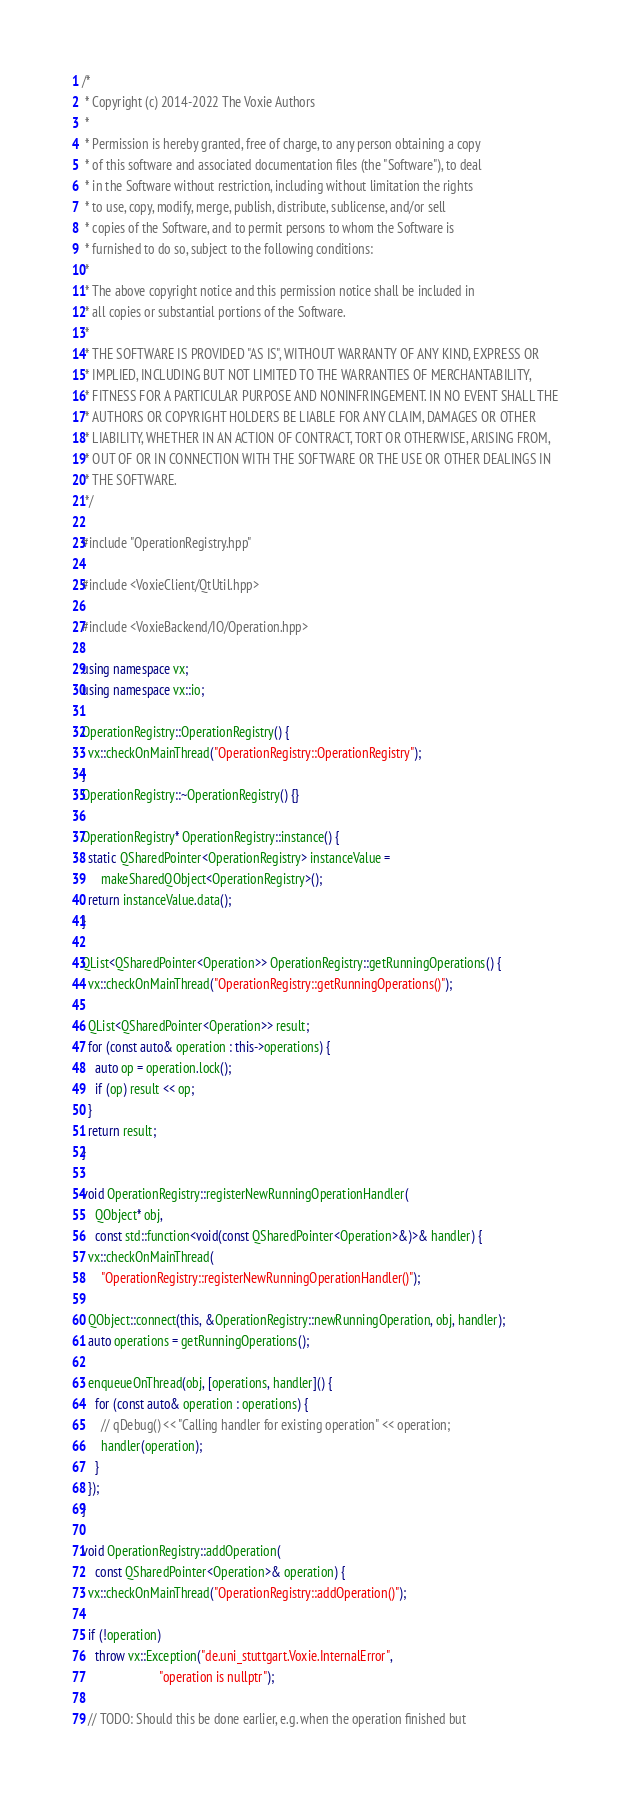Convert code to text. <code><loc_0><loc_0><loc_500><loc_500><_C++_>/*
 * Copyright (c) 2014-2022 The Voxie Authors
 *
 * Permission is hereby granted, free of charge, to any person obtaining a copy
 * of this software and associated documentation files (the "Software"), to deal
 * in the Software without restriction, including without limitation the rights
 * to use, copy, modify, merge, publish, distribute, sublicense, and/or sell
 * copies of the Software, and to permit persons to whom the Software is
 * furnished to do so, subject to the following conditions:
 *
 * The above copyright notice and this permission notice shall be included in
 * all copies or substantial portions of the Software.
 *
 * THE SOFTWARE IS PROVIDED "AS IS", WITHOUT WARRANTY OF ANY KIND, EXPRESS OR
 * IMPLIED, INCLUDING BUT NOT LIMITED TO THE WARRANTIES OF MERCHANTABILITY,
 * FITNESS FOR A PARTICULAR PURPOSE AND NONINFRINGEMENT. IN NO EVENT SHALL THE
 * AUTHORS OR COPYRIGHT HOLDERS BE LIABLE FOR ANY CLAIM, DAMAGES OR OTHER
 * LIABILITY, WHETHER IN AN ACTION OF CONTRACT, TORT OR OTHERWISE, ARISING FROM,
 * OUT OF OR IN CONNECTION WITH THE SOFTWARE OR THE USE OR OTHER DEALINGS IN
 * THE SOFTWARE.
 */

#include "OperationRegistry.hpp"

#include <VoxieClient/QtUtil.hpp>

#include <VoxieBackend/IO/Operation.hpp>

using namespace vx;
using namespace vx::io;

OperationRegistry::OperationRegistry() {
  vx::checkOnMainThread("OperationRegistry::OperationRegistry");
}
OperationRegistry::~OperationRegistry() {}

OperationRegistry* OperationRegistry::instance() {
  static QSharedPointer<OperationRegistry> instanceValue =
      makeSharedQObject<OperationRegistry>();
  return instanceValue.data();
}

QList<QSharedPointer<Operation>> OperationRegistry::getRunningOperations() {
  vx::checkOnMainThread("OperationRegistry::getRunningOperations()");

  QList<QSharedPointer<Operation>> result;
  for (const auto& operation : this->operations) {
    auto op = operation.lock();
    if (op) result << op;
  }
  return result;
}

void OperationRegistry::registerNewRunningOperationHandler(
    QObject* obj,
    const std::function<void(const QSharedPointer<Operation>&)>& handler) {
  vx::checkOnMainThread(
      "OperationRegistry::registerNewRunningOperationHandler()");

  QObject::connect(this, &OperationRegistry::newRunningOperation, obj, handler);
  auto operations = getRunningOperations();

  enqueueOnThread(obj, [operations, handler]() {
    for (const auto& operation : operations) {
      // qDebug() << "Calling handler for existing operation" << operation;
      handler(operation);
    }
  });
}

void OperationRegistry::addOperation(
    const QSharedPointer<Operation>& operation) {
  vx::checkOnMainThread("OperationRegistry::addOperation()");

  if (!operation)
    throw vx::Exception("de.uni_stuttgart.Voxie.InternalError",
                        "operation is nullptr");

  // TODO: Should this be done earlier, e.g. when the operation finished but</code> 